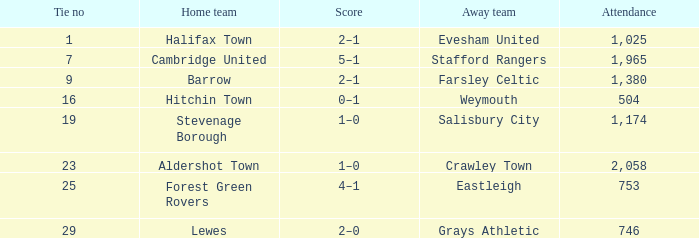Who was the away team in a tie no larger than 16 with forest green rovers at home? Eastleigh. 